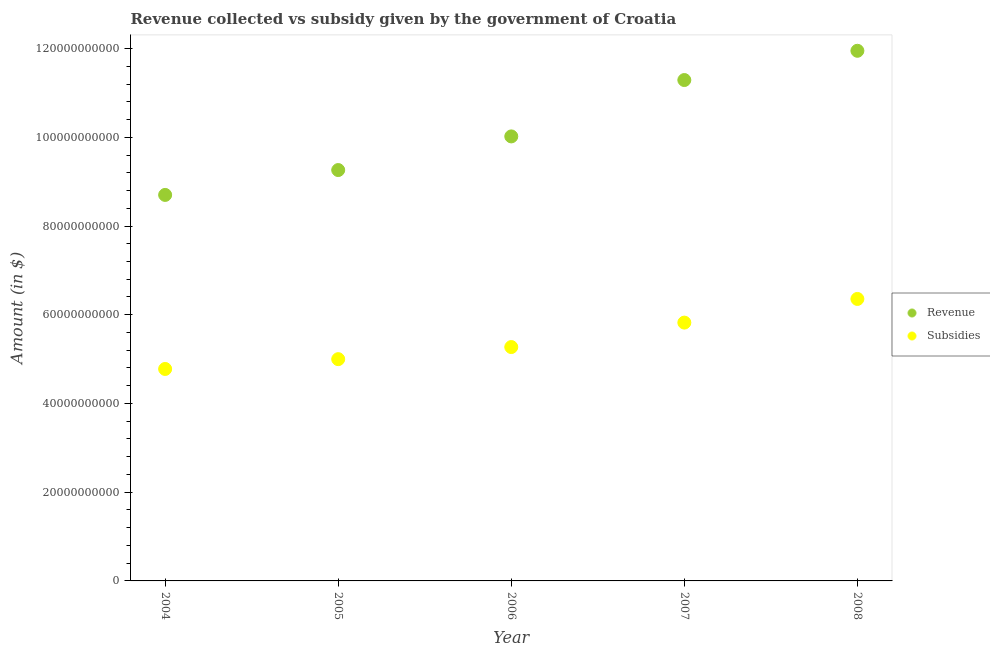What is the amount of subsidies given in 2005?
Give a very brief answer. 5.00e+1. Across all years, what is the maximum amount of subsidies given?
Offer a terse response. 6.36e+1. Across all years, what is the minimum amount of subsidies given?
Ensure brevity in your answer.  4.78e+1. In which year was the amount of revenue collected maximum?
Offer a terse response. 2008. In which year was the amount of subsidies given minimum?
Offer a terse response. 2004. What is the total amount of subsidies given in the graph?
Your answer should be compact. 2.72e+11. What is the difference between the amount of revenue collected in 2004 and that in 2005?
Offer a very short reply. -5.61e+09. What is the difference between the amount of subsidies given in 2007 and the amount of revenue collected in 2006?
Offer a terse response. -4.20e+1. What is the average amount of subsidies given per year?
Provide a short and direct response. 5.45e+1. In the year 2006, what is the difference between the amount of subsidies given and amount of revenue collected?
Your answer should be compact. -4.75e+1. In how many years, is the amount of subsidies given greater than 76000000000 $?
Provide a short and direct response. 0. What is the ratio of the amount of subsidies given in 2005 to that in 2008?
Make the answer very short. 0.79. Is the amount of revenue collected in 2004 less than that in 2007?
Your response must be concise. Yes. Is the difference between the amount of revenue collected in 2007 and 2008 greater than the difference between the amount of subsidies given in 2007 and 2008?
Offer a very short reply. No. What is the difference between the highest and the second highest amount of subsidies given?
Keep it short and to the point. 5.33e+09. What is the difference between the highest and the lowest amount of revenue collected?
Offer a very short reply. 3.25e+1. In how many years, is the amount of subsidies given greater than the average amount of subsidies given taken over all years?
Make the answer very short. 2. Is the sum of the amount of revenue collected in 2004 and 2005 greater than the maximum amount of subsidies given across all years?
Offer a terse response. Yes. Is the amount of revenue collected strictly greater than the amount of subsidies given over the years?
Provide a succinct answer. Yes. Is the amount of subsidies given strictly less than the amount of revenue collected over the years?
Make the answer very short. Yes. How many years are there in the graph?
Provide a succinct answer. 5. What is the difference between two consecutive major ticks on the Y-axis?
Keep it short and to the point. 2.00e+1. Does the graph contain grids?
Ensure brevity in your answer.  No. Where does the legend appear in the graph?
Your answer should be very brief. Center right. How many legend labels are there?
Make the answer very short. 2. How are the legend labels stacked?
Your answer should be very brief. Vertical. What is the title of the graph?
Ensure brevity in your answer.  Revenue collected vs subsidy given by the government of Croatia. Does "Age 65(female)" appear as one of the legend labels in the graph?
Your answer should be compact. No. What is the label or title of the Y-axis?
Ensure brevity in your answer.  Amount (in $). What is the Amount (in $) in Revenue in 2004?
Offer a terse response. 8.70e+1. What is the Amount (in $) in Subsidies in 2004?
Offer a terse response. 4.78e+1. What is the Amount (in $) in Revenue in 2005?
Keep it short and to the point. 9.26e+1. What is the Amount (in $) in Subsidies in 2005?
Give a very brief answer. 5.00e+1. What is the Amount (in $) in Revenue in 2006?
Your answer should be compact. 1.00e+11. What is the Amount (in $) in Subsidies in 2006?
Your answer should be compact. 5.27e+1. What is the Amount (in $) of Revenue in 2007?
Keep it short and to the point. 1.13e+11. What is the Amount (in $) of Subsidies in 2007?
Keep it short and to the point. 5.82e+1. What is the Amount (in $) of Revenue in 2008?
Keep it short and to the point. 1.19e+11. What is the Amount (in $) of Subsidies in 2008?
Offer a terse response. 6.36e+1. Across all years, what is the maximum Amount (in $) in Revenue?
Provide a short and direct response. 1.19e+11. Across all years, what is the maximum Amount (in $) of Subsidies?
Provide a short and direct response. 6.36e+1. Across all years, what is the minimum Amount (in $) in Revenue?
Your response must be concise. 8.70e+1. Across all years, what is the minimum Amount (in $) of Subsidies?
Provide a succinct answer. 4.78e+1. What is the total Amount (in $) of Revenue in the graph?
Your answer should be very brief. 5.12e+11. What is the total Amount (in $) of Subsidies in the graph?
Offer a very short reply. 2.72e+11. What is the difference between the Amount (in $) of Revenue in 2004 and that in 2005?
Your answer should be very brief. -5.61e+09. What is the difference between the Amount (in $) in Subsidies in 2004 and that in 2005?
Your answer should be compact. -2.21e+09. What is the difference between the Amount (in $) of Revenue in 2004 and that in 2006?
Ensure brevity in your answer.  -1.32e+1. What is the difference between the Amount (in $) of Subsidies in 2004 and that in 2006?
Your answer should be compact. -4.94e+09. What is the difference between the Amount (in $) of Revenue in 2004 and that in 2007?
Provide a succinct answer. -2.59e+1. What is the difference between the Amount (in $) of Subsidies in 2004 and that in 2007?
Provide a short and direct response. -1.05e+1. What is the difference between the Amount (in $) of Revenue in 2004 and that in 2008?
Your answer should be compact. -3.25e+1. What is the difference between the Amount (in $) of Subsidies in 2004 and that in 2008?
Your response must be concise. -1.58e+1. What is the difference between the Amount (in $) in Revenue in 2005 and that in 2006?
Provide a short and direct response. -7.58e+09. What is the difference between the Amount (in $) of Subsidies in 2005 and that in 2006?
Your answer should be very brief. -2.73e+09. What is the difference between the Amount (in $) of Revenue in 2005 and that in 2007?
Make the answer very short. -2.03e+1. What is the difference between the Amount (in $) of Subsidies in 2005 and that in 2007?
Keep it short and to the point. -8.24e+09. What is the difference between the Amount (in $) of Revenue in 2005 and that in 2008?
Provide a short and direct response. -2.69e+1. What is the difference between the Amount (in $) of Subsidies in 2005 and that in 2008?
Make the answer very short. -1.36e+1. What is the difference between the Amount (in $) in Revenue in 2006 and that in 2007?
Keep it short and to the point. -1.27e+1. What is the difference between the Amount (in $) of Subsidies in 2006 and that in 2007?
Give a very brief answer. -5.51e+09. What is the difference between the Amount (in $) of Revenue in 2006 and that in 2008?
Provide a short and direct response. -1.93e+1. What is the difference between the Amount (in $) of Subsidies in 2006 and that in 2008?
Provide a succinct answer. -1.08e+1. What is the difference between the Amount (in $) in Revenue in 2007 and that in 2008?
Ensure brevity in your answer.  -6.59e+09. What is the difference between the Amount (in $) of Subsidies in 2007 and that in 2008?
Give a very brief answer. -5.33e+09. What is the difference between the Amount (in $) of Revenue in 2004 and the Amount (in $) of Subsidies in 2005?
Keep it short and to the point. 3.70e+1. What is the difference between the Amount (in $) of Revenue in 2004 and the Amount (in $) of Subsidies in 2006?
Provide a succinct answer. 3.43e+1. What is the difference between the Amount (in $) of Revenue in 2004 and the Amount (in $) of Subsidies in 2007?
Ensure brevity in your answer.  2.88e+1. What is the difference between the Amount (in $) in Revenue in 2004 and the Amount (in $) in Subsidies in 2008?
Your answer should be compact. 2.34e+1. What is the difference between the Amount (in $) of Revenue in 2005 and the Amount (in $) of Subsidies in 2006?
Provide a succinct answer. 3.99e+1. What is the difference between the Amount (in $) in Revenue in 2005 and the Amount (in $) in Subsidies in 2007?
Ensure brevity in your answer.  3.44e+1. What is the difference between the Amount (in $) of Revenue in 2005 and the Amount (in $) of Subsidies in 2008?
Provide a succinct answer. 2.91e+1. What is the difference between the Amount (in $) in Revenue in 2006 and the Amount (in $) in Subsidies in 2007?
Your response must be concise. 4.20e+1. What is the difference between the Amount (in $) in Revenue in 2006 and the Amount (in $) in Subsidies in 2008?
Your answer should be compact. 3.66e+1. What is the difference between the Amount (in $) of Revenue in 2007 and the Amount (in $) of Subsidies in 2008?
Your answer should be very brief. 4.93e+1. What is the average Amount (in $) of Revenue per year?
Provide a succinct answer. 1.02e+11. What is the average Amount (in $) in Subsidies per year?
Ensure brevity in your answer.  5.45e+1. In the year 2004, what is the difference between the Amount (in $) of Revenue and Amount (in $) of Subsidies?
Your answer should be compact. 3.92e+1. In the year 2005, what is the difference between the Amount (in $) of Revenue and Amount (in $) of Subsidies?
Provide a succinct answer. 4.26e+1. In the year 2006, what is the difference between the Amount (in $) of Revenue and Amount (in $) of Subsidies?
Your answer should be compact. 4.75e+1. In the year 2007, what is the difference between the Amount (in $) of Revenue and Amount (in $) of Subsidies?
Offer a very short reply. 5.47e+1. In the year 2008, what is the difference between the Amount (in $) of Revenue and Amount (in $) of Subsidies?
Provide a succinct answer. 5.59e+1. What is the ratio of the Amount (in $) in Revenue in 2004 to that in 2005?
Your answer should be compact. 0.94. What is the ratio of the Amount (in $) of Subsidies in 2004 to that in 2005?
Give a very brief answer. 0.96. What is the ratio of the Amount (in $) in Revenue in 2004 to that in 2006?
Your response must be concise. 0.87. What is the ratio of the Amount (in $) in Subsidies in 2004 to that in 2006?
Offer a very short reply. 0.91. What is the ratio of the Amount (in $) of Revenue in 2004 to that in 2007?
Your response must be concise. 0.77. What is the ratio of the Amount (in $) in Subsidies in 2004 to that in 2007?
Your answer should be very brief. 0.82. What is the ratio of the Amount (in $) in Revenue in 2004 to that in 2008?
Keep it short and to the point. 0.73. What is the ratio of the Amount (in $) in Subsidies in 2004 to that in 2008?
Make the answer very short. 0.75. What is the ratio of the Amount (in $) in Revenue in 2005 to that in 2006?
Keep it short and to the point. 0.92. What is the ratio of the Amount (in $) of Subsidies in 2005 to that in 2006?
Make the answer very short. 0.95. What is the ratio of the Amount (in $) in Revenue in 2005 to that in 2007?
Offer a terse response. 0.82. What is the ratio of the Amount (in $) of Subsidies in 2005 to that in 2007?
Your answer should be compact. 0.86. What is the ratio of the Amount (in $) in Revenue in 2005 to that in 2008?
Offer a very short reply. 0.78. What is the ratio of the Amount (in $) of Subsidies in 2005 to that in 2008?
Offer a terse response. 0.79. What is the ratio of the Amount (in $) in Revenue in 2006 to that in 2007?
Your answer should be compact. 0.89. What is the ratio of the Amount (in $) in Subsidies in 2006 to that in 2007?
Make the answer very short. 0.91. What is the ratio of the Amount (in $) in Revenue in 2006 to that in 2008?
Offer a terse response. 0.84. What is the ratio of the Amount (in $) in Subsidies in 2006 to that in 2008?
Provide a short and direct response. 0.83. What is the ratio of the Amount (in $) of Revenue in 2007 to that in 2008?
Offer a very short reply. 0.94. What is the ratio of the Amount (in $) in Subsidies in 2007 to that in 2008?
Provide a succinct answer. 0.92. What is the difference between the highest and the second highest Amount (in $) in Revenue?
Your answer should be compact. 6.59e+09. What is the difference between the highest and the second highest Amount (in $) of Subsidies?
Ensure brevity in your answer.  5.33e+09. What is the difference between the highest and the lowest Amount (in $) in Revenue?
Your answer should be very brief. 3.25e+1. What is the difference between the highest and the lowest Amount (in $) of Subsidies?
Ensure brevity in your answer.  1.58e+1. 